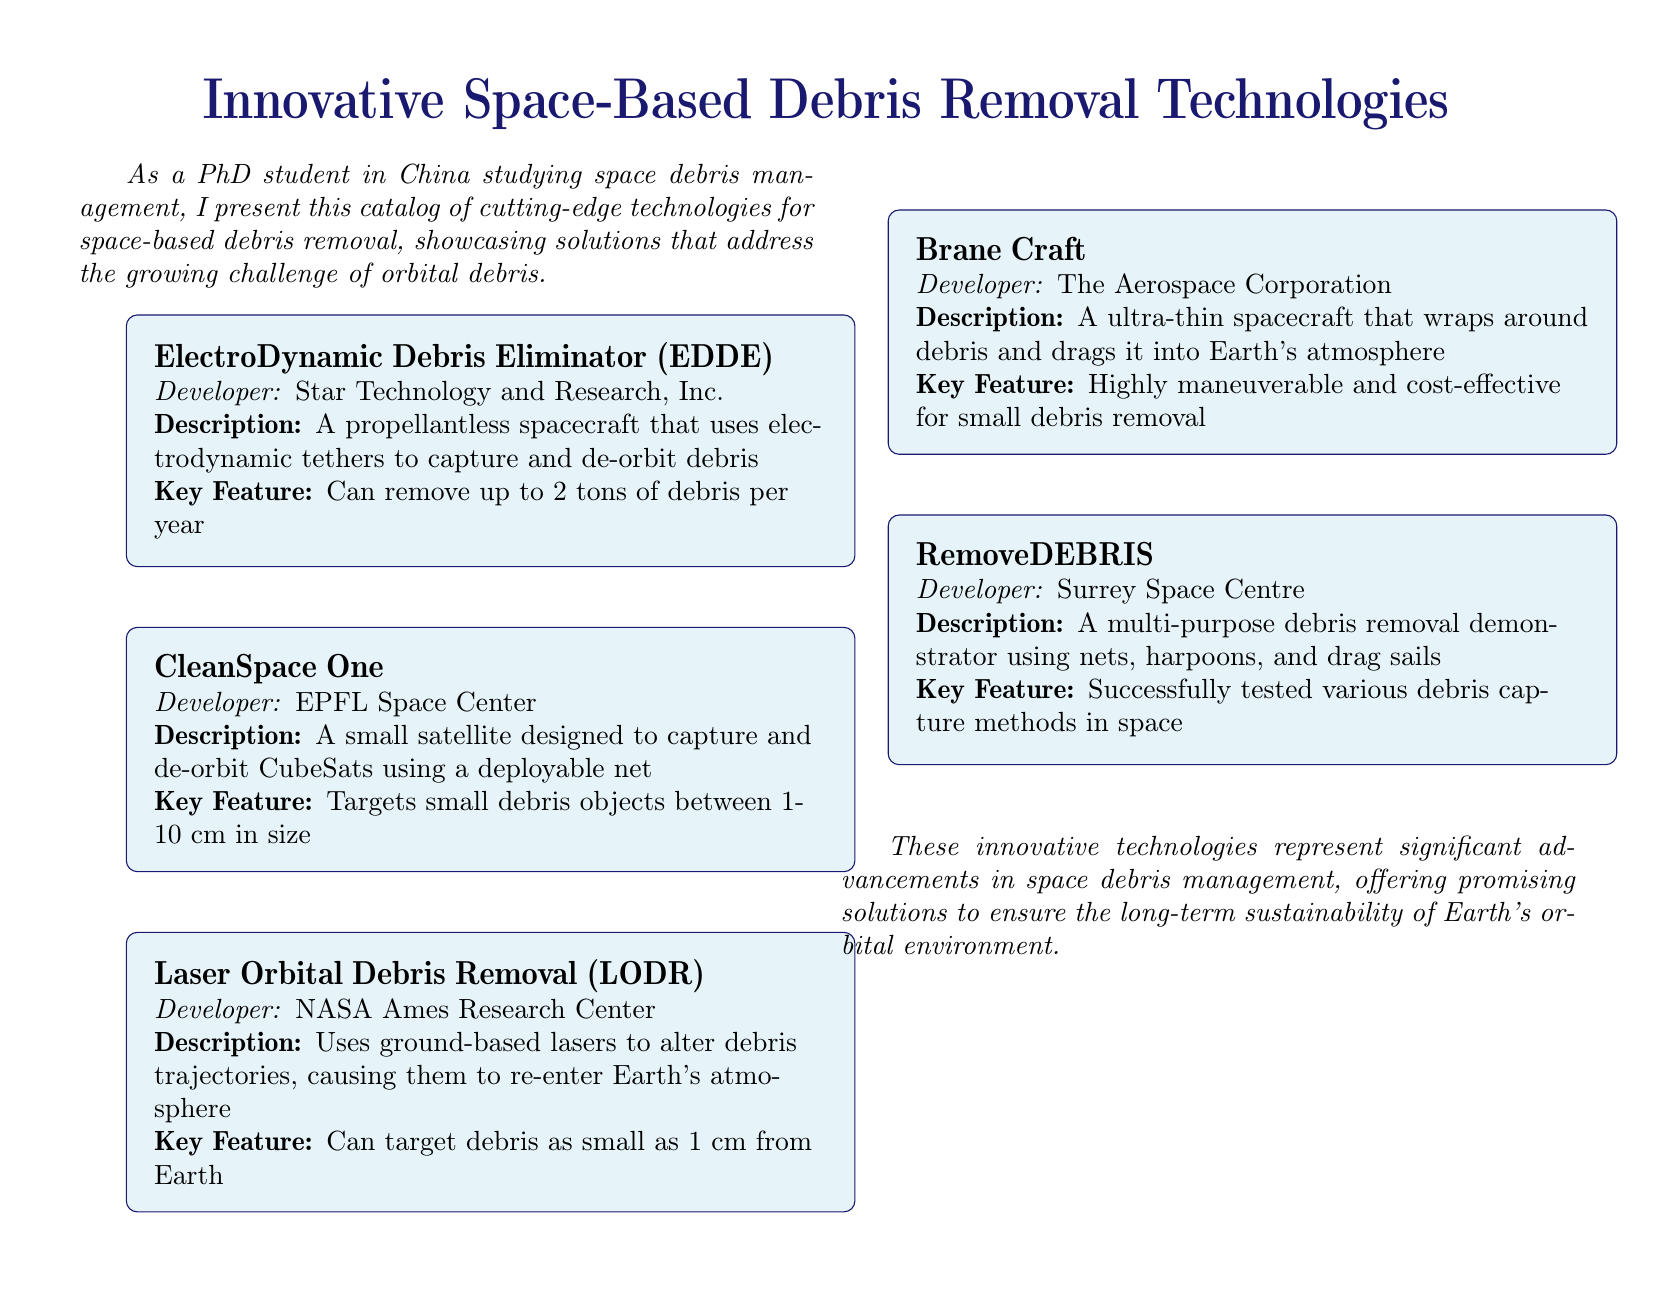what is the name of the debris removal technology developed by Star Technology and Research, Inc.? The catalog lists the technology as "ElectroDynamic Debris Eliminator (EDDE)."
Answer: ElectroDynamic Debris Eliminator (EDDE) how much debris can the CleanSpace One capture? The document states that CleanSpace One targets small debris objects between 1-10 cm in size.
Answer: 1-10 cm which organization developed the Laser Orbital Debris Removal technology? According to the document, the technology is developed by NASA Ames Research Center.
Answer: NASA Ames Research Center what is the key feature of RemoveDEBRIS technology? The document describes it as a multi-purpose debris removal demonstrator using nets, harpoons, and drag sails.
Answer: Multi-purpose debris removal demonstrator using nets, harpoons, and drag sails what year is stated for the annual debris removal capacity of the EDDE technology? The catalog mentions that the EDDE can remove up to 2 tons of debris **per year**.
Answer: per year which technology is designed to capture CubeSats? The document indicates that CleanSpace One is designed for this purpose.
Answer: CleanSpace One how does the Brane Craft remove debris? The document states that it wraps around debris and drags it into Earth's atmosphere.
Answer: Wraps around debris and drags it into Earth's atmosphere what does the description of Laser Orbital Debris Removal mention about targeting debris sizes? The text states it can target debris as small as 1 cm from Earth.
Answer: 1 cm what type of document is this? The format and content categorize it as a catalog showcasing innovative debris removal technologies.
Answer: Catalog 